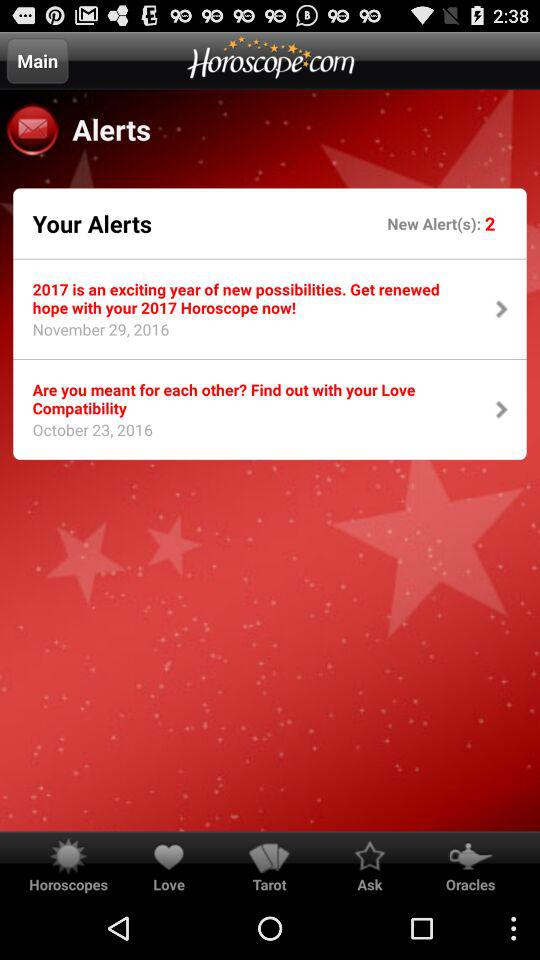What is the number of new alerts? The number of new alerts is 2. 